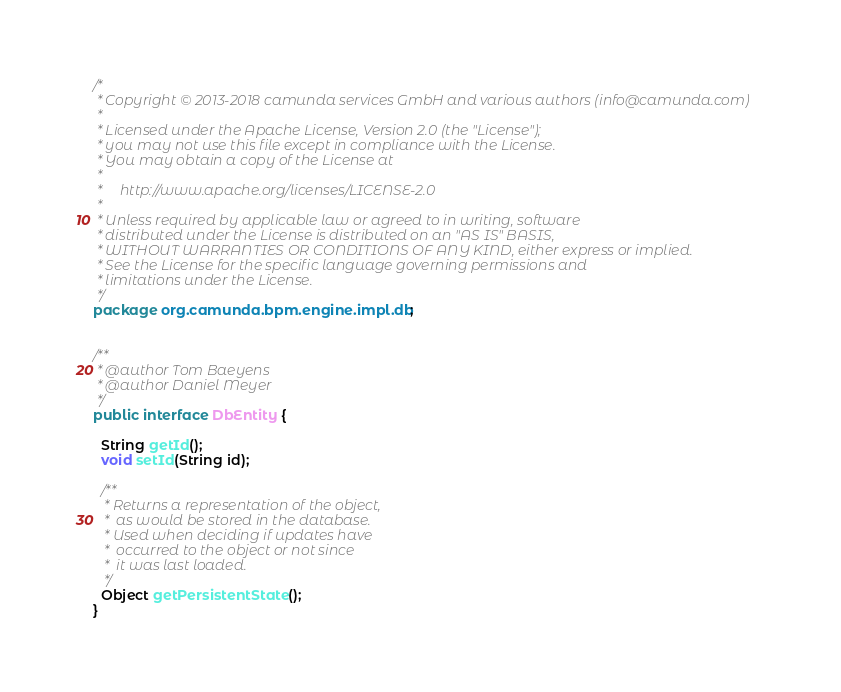Convert code to text. <code><loc_0><loc_0><loc_500><loc_500><_Java_>/*
 * Copyright © 2013-2018 camunda services GmbH and various authors (info@camunda.com)
 *
 * Licensed under the Apache License, Version 2.0 (the "License");
 * you may not use this file except in compliance with the License.
 * You may obtain a copy of the License at
 *
 *     http://www.apache.org/licenses/LICENSE-2.0
 *
 * Unless required by applicable law or agreed to in writing, software
 * distributed under the License is distributed on an "AS IS" BASIS,
 * WITHOUT WARRANTIES OR CONDITIONS OF ANY KIND, either express or implied.
 * See the License for the specific language governing permissions and
 * limitations under the License.
 */
package org.camunda.bpm.engine.impl.db;


/**
 * @author Tom Baeyens
 * @author Daniel Meyer
 */
public interface DbEntity {

  String getId();
  void setId(String id);

  /**
   * Returns a representation of the object,
   *  as would be stored in the database.
   * Used when deciding if updates have
   *  occurred to the object or not since
   *  it was last loaded.
   */
  Object getPersistentState();
}
</code> 